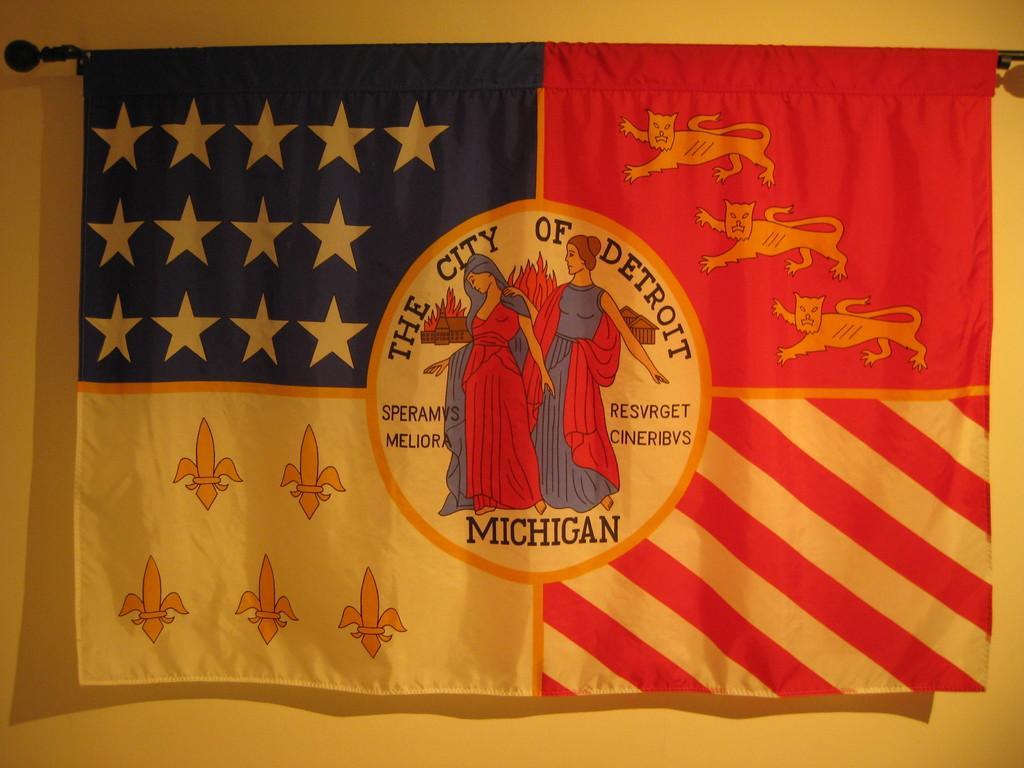Describe this image in one or two sentences. There is a picture of two women's on a flag as we can see in the middle of this image, and there is a wall in the background. 